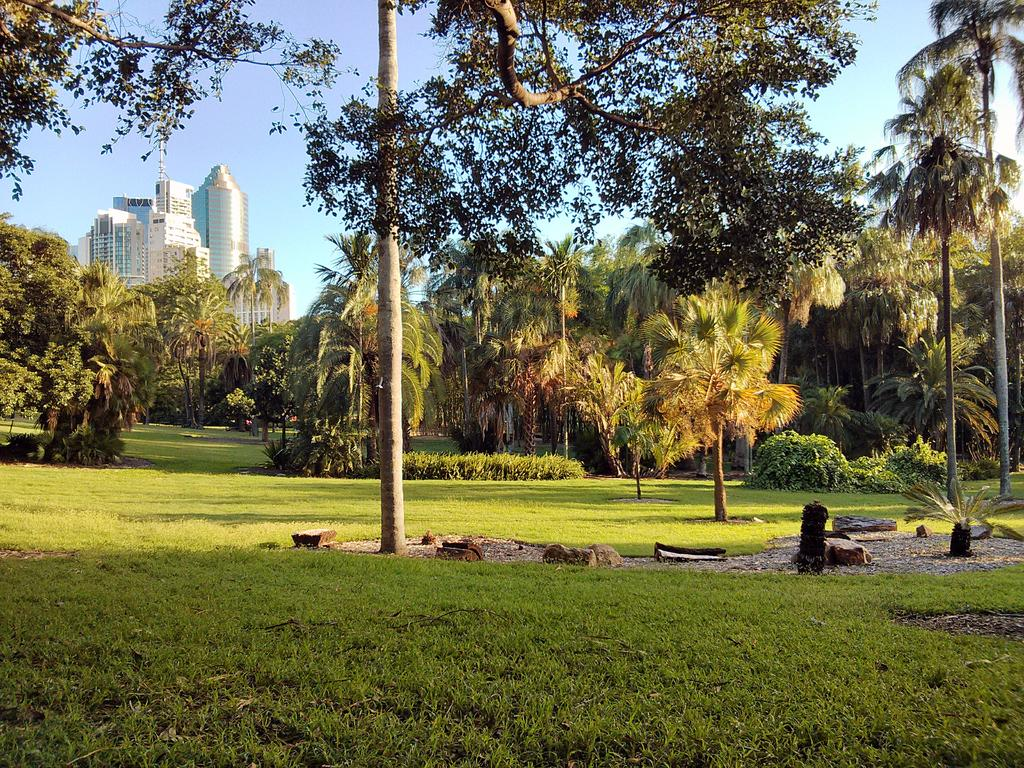What type of vegetation can be seen in the image? There are trees in the image. What area is visible in the image? There is a garden area in the image. What can be seen in the background of the image? There are buildings in the background of the image. What is visible in the sky in the image? The sky is clear and visible in the background of the image. What type of locket does the father offer to the person in the image? There is no father or person present in the image, and therefore no such interaction can be observed. What type of offer is made by the father in the image? There is no father or offer present in the image. 